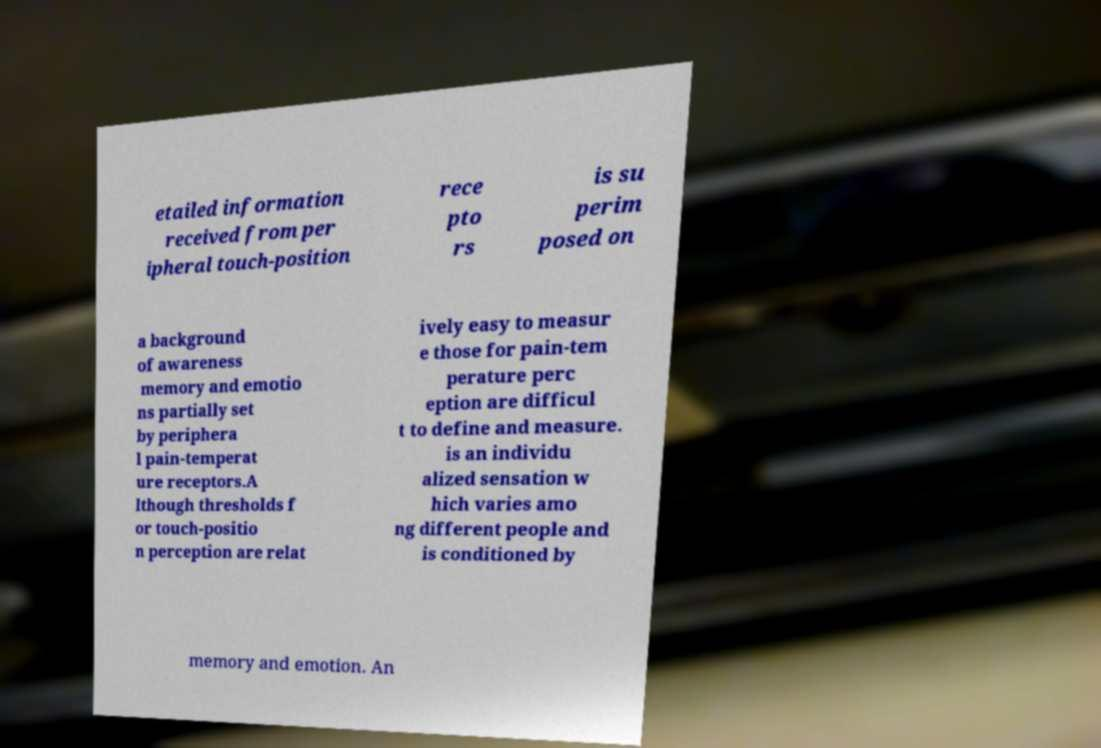Could you assist in decoding the text presented in this image and type it out clearly? etailed information received from per ipheral touch-position rece pto rs is su perim posed on a background of awareness memory and emotio ns partially set by periphera l pain-temperat ure receptors.A lthough thresholds f or touch-positio n perception are relat ively easy to measur e those for pain-tem perature perc eption are difficul t to define and measure. is an individu alized sensation w hich varies amo ng different people and is conditioned by memory and emotion. An 